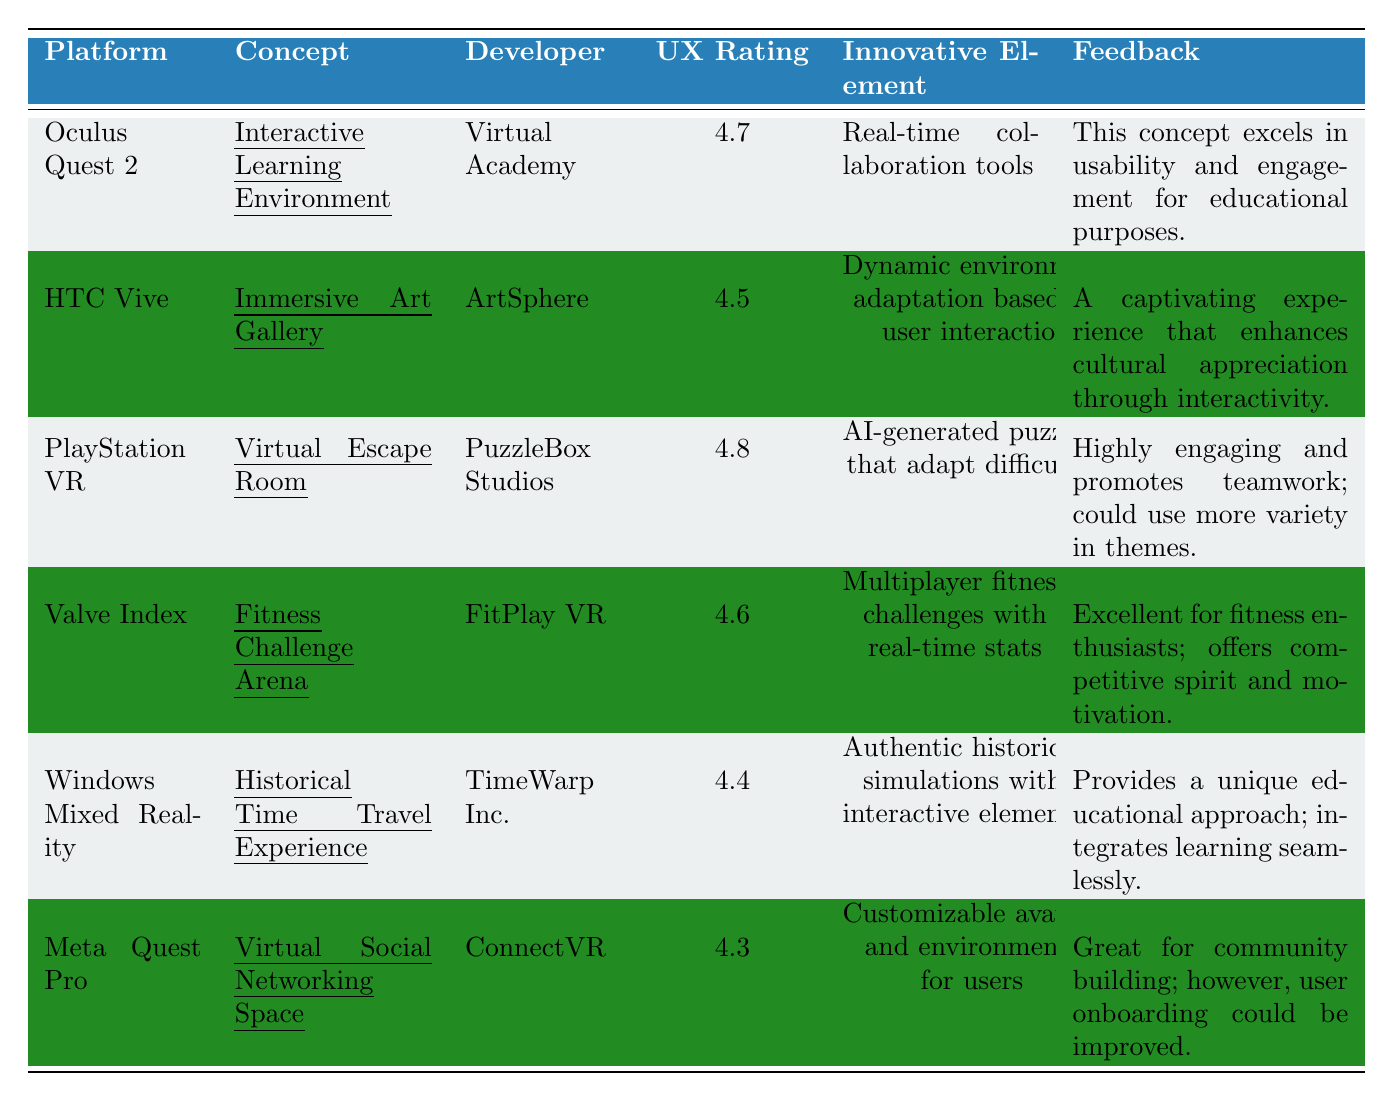What is the user experience rating for the "Virtual Escape Room"? The table indicates that the user experience rating for the "Virtual Escape Room" is listed in the relevant row, which shows a value of 4.8.
Answer: 4.8 Which platform has the highest user experience rating? By comparing the user experience ratings listed for each platform, "PlayStation VR" has the highest rating at 4.8.
Answer: PlayStation VR Is there any concept related to social networking in the table? Yes, "Virtual Social Networking Space" under the Meta Quest Pro platform is the only concept related to social networking.
Answer: Yes What is the average user experience rating for all the concepts listed? To find the average, sum the user experience ratings: 4.7 + 4.5 + 4.8 + 4.6 + 4.4 + 4.3 = 27.3. There are 6 concepts so the average is 27.3 / 6 = 4.55.
Answer: 4.55 Which innovative element is described for the "Immersive Art Gallery"? The table specifies that the innovative element for the "Immersive Art Gallery" is "Dynamic environment adaptation based on user interaction."
Answer: Dynamic environment adaptation based on user interaction Which concept has the lowest user experience rating and what is that rating? By reviewing the user experience ratings, "Virtual Social Networking Space" under the Meta Quest Pro has the lowest rating at 4.3.
Answer: 4.3 How many concepts have a user experience rating above 4.5? The ratings above 4.5 are for "Interactive Learning Environment" (4.7), "Virtual Escape Room" (4.8), and "Fitness Challenge Arena" (4.6). This gives us a total of 3 concepts.
Answer: 3 Is the feedback for "Historical Time Travel Experience" positive or negative? The feedback for "Historical Time Travel Experience" indicates it provides a unique educational approach and integrates learning seamlessly, which is positive in nature.
Answer: Positive Which platform features a concept that includes multiplayer fitness challenges? The "Fitness Challenge Arena" concept is featured on the Valve Index platform, which includes multiplayer fitness challenges.
Answer: Valve Index If you were to compile a list of feedback comments, how many concepts indicate a need for improvement? The concepts that indicate a need for improvement are "Virtual Escape Room," which suggests more variety in themes, and "Virtual Social Networking Space," which mentions improvements in user onboarding. Therefore, there are 2 concepts needing improvement.
Answer: 2 